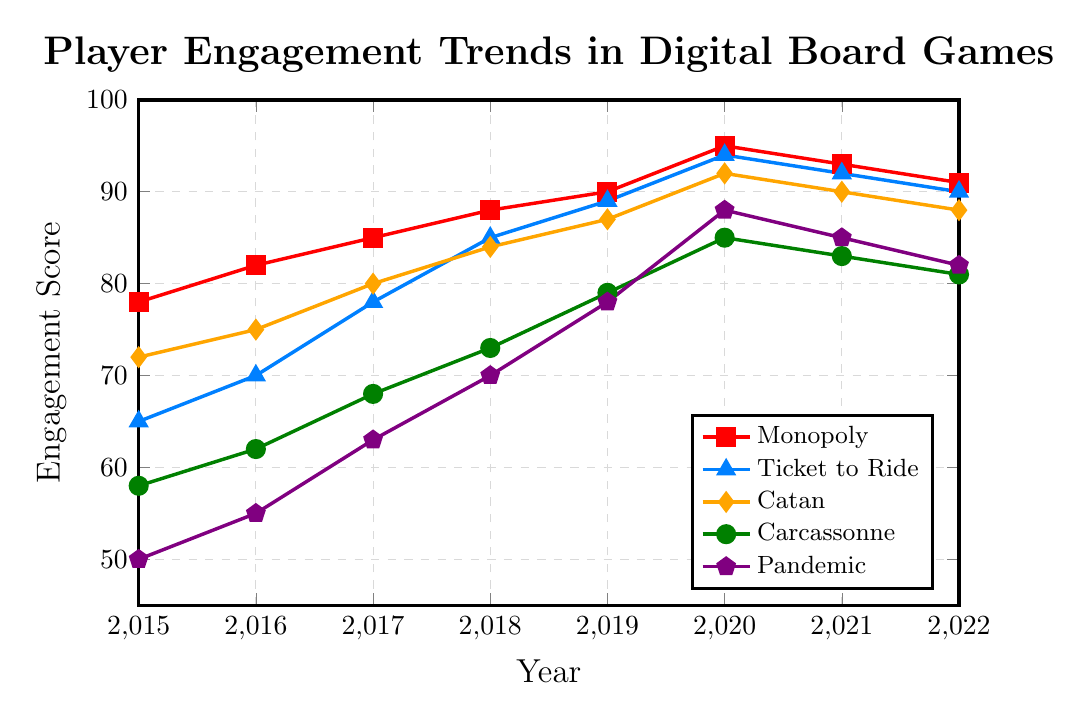What's the trend of player engagement for the game Monopoly over the years? To identify the trend, we observe the engagement scores for Monopoly from 2015 to 2022. The scores show a general increase from 78 in 2015 to a peak of 95 in 2020, then a slight decline to 91 by 2022. This depicts an upward trend peaking in 2020, followed by a minor drop.
Answer: Upward trend peaking in 2020, then a slight decline Which game had the highest engagement score in 2020? By examining the engagement scores for each game in 2020, we find the scores are as follows: Monopoly (95), Ticket to Ride (94), Catan (92), Carcassonne (85), and Pandemic (88). Monopoly has the highest score among all the games.
Answer: Monopoly How does the engagement score for Pandemic in 2015 compare to that in 2022? The engagement score for Pandemic in 2015 is 50, and in 2022 is 82. Comparing these two values, we see an increase of 32 points from 2015 to 2022.
Answer: 32 points increase Which game showed the most consistent increase in engagement from 2015 to 2020? Looking at the incremental changes for each year from 2015 to 2020, Ticket to Ride and Pandemic both show consistent increases every year. However, Ticket to Ride increases from 65 to 94, while Pandemic increases from 50 to 88, indicating that both have consistent increases, but Ticket to Ride shows a larger cumulative increase over time.
Answer: Ticket to Ride Comparing the lowest engagement in 2015 and 2022, how much has it changed? In 2015, the lowest engagement score is for Pandemic at 50. In 2022, the lowest score is for Pandemic again at 82. The change is 82 - 50 = 32.
Answer: 32 points increase Which two games have the closest engagement scores in 2021? In 2021, the engagement scores are: Monopoly (93), Ticket to Ride (92), Catan (90), Carcassonne (83), and Pandemic (85). Ticket to Ride and Monopoly have the closest scores, differing by just 1 point.
Answer: Ticket to Ride and Monopoly What is the average engagement score for Catan from 2015 to 2022? Adding the scores for Catan from each year: 72 + 75 + 80 + 84 + 87 + 92 + 90 + 88 yields 668. Dividing this sum by 8 (the number of years) gives 668 / 8 = 83.5.
Answer: 83.5 Which game's engagement score declined the most from its peak year to 2022? First, identify the peak year for each game and the corresponding score: Monopoly peaked at 95 in 2020, Ticket to Ride at 94 in 2020, Catan at 92 in 2020, Carcassonne at 85 in 2020, and Pandemic at 88 in 2020. Compare these peak scores to their 2022 scores – declines are: Monopoly (4), Ticket to Ride (4), Catan (4), Carcassonne (4), and Pandemic (6). Pandemic shows the largest decline.
Answer: Pandemic What is the cumulative increase in engagement for Carcassonne from 2015 to 2020? Calculate the increase each year for Carcassonne: (62-58) + (68-62) + (73-68) + (79-73) + (85-79) = 4 + 6 + 5 + 6 + 6 = 27. So the cumulative increase from 2015 to 2020 is 27.
Answer: 27 points By how many points did the engagement score for Ticket to Ride increase between 2018 and 2020? The engagement score for Ticket to Ride in 2018 is 85 and in 2020 is 94. The increase is 94 - 85 = 9 points.
Answer: 9 points 